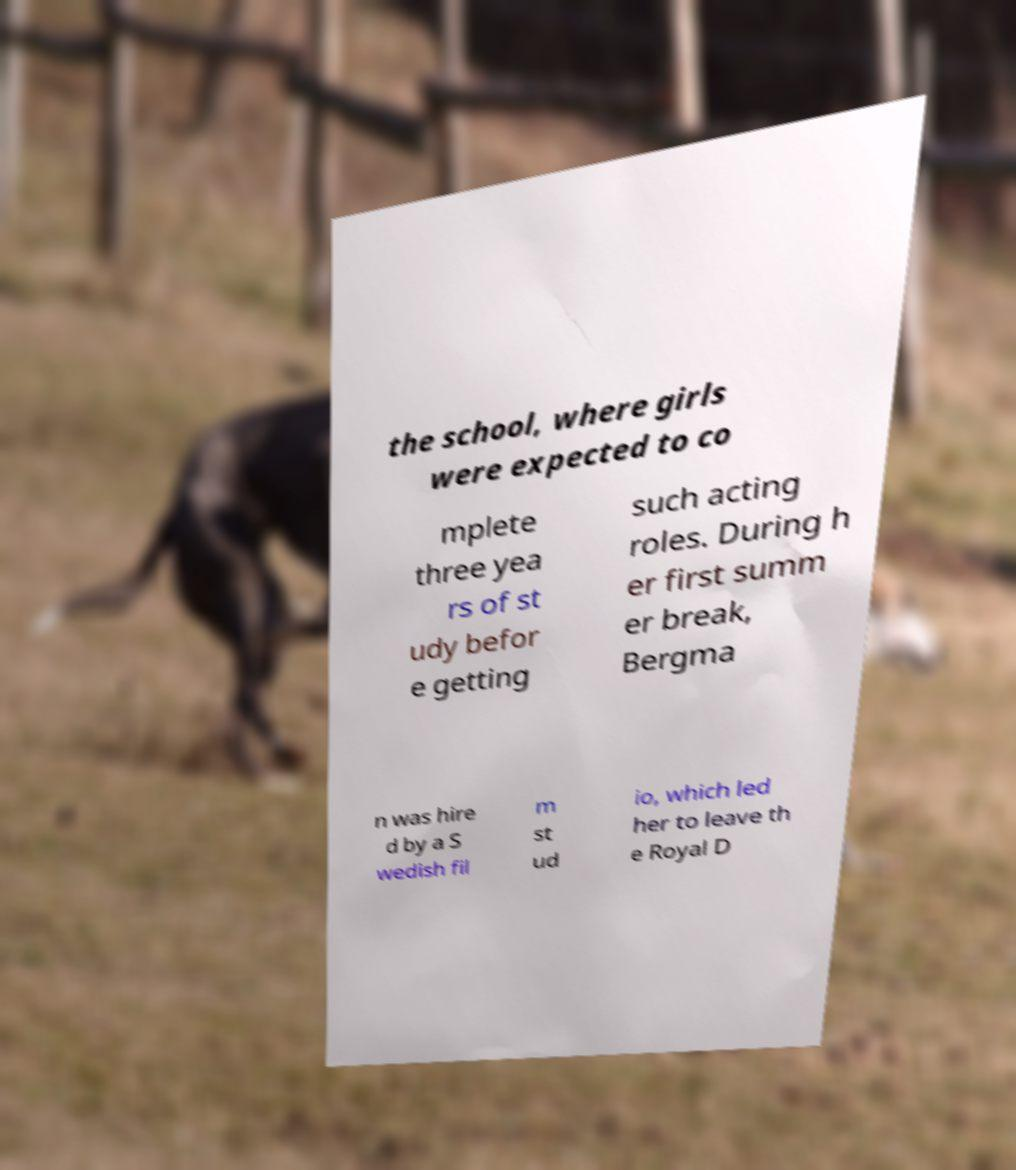Could you extract and type out the text from this image? the school, where girls were expected to co mplete three yea rs of st udy befor e getting such acting roles. During h er first summ er break, Bergma n was hire d by a S wedish fil m st ud io, which led her to leave th e Royal D 